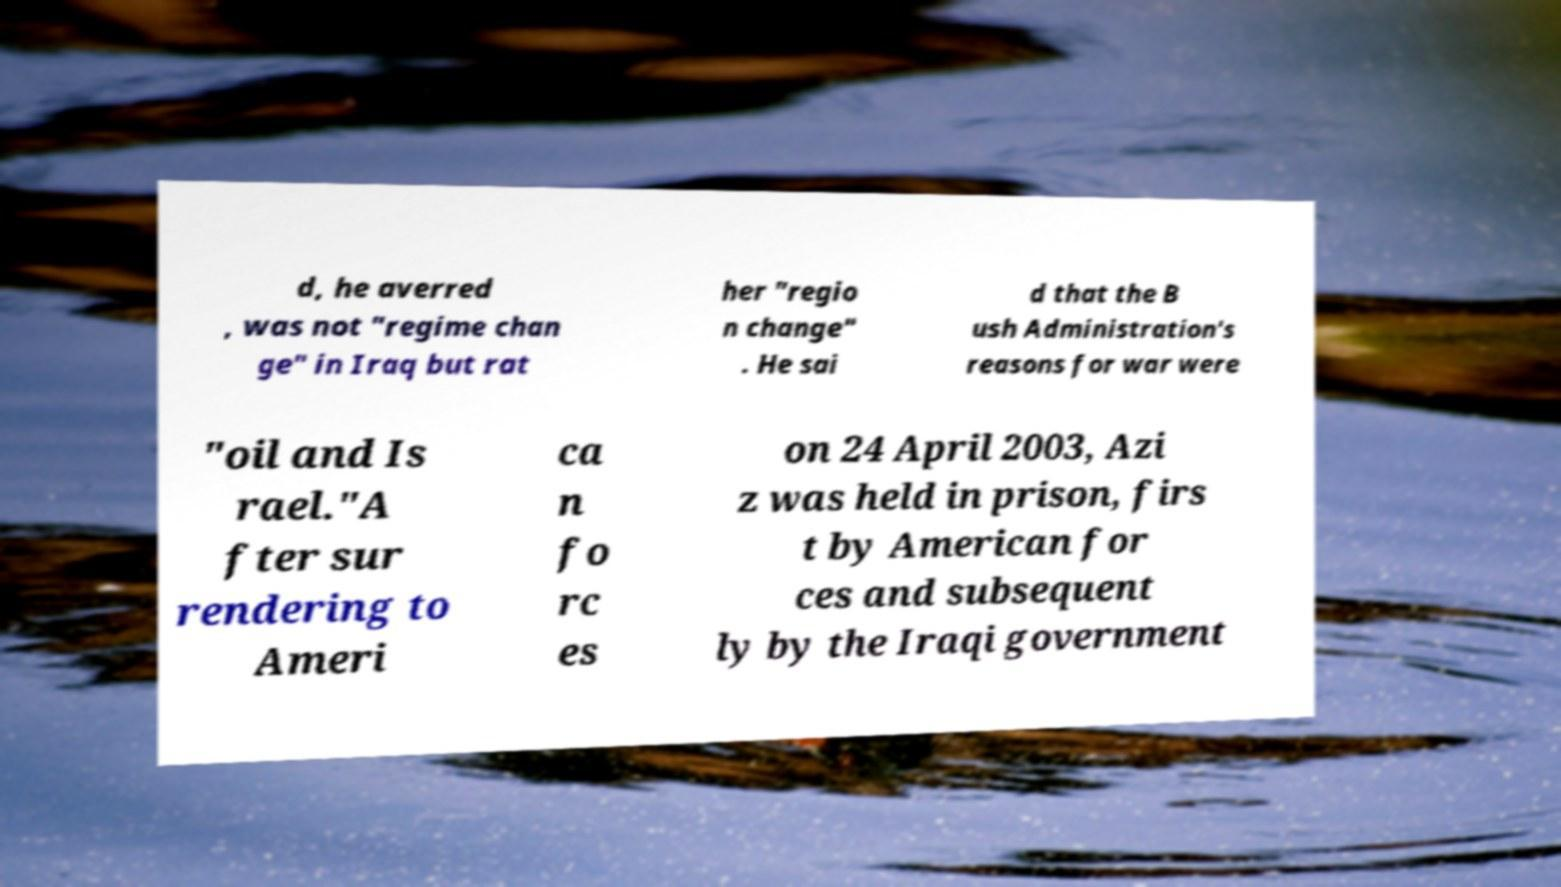Can you read and provide the text displayed in the image?This photo seems to have some interesting text. Can you extract and type it out for me? d, he averred , was not "regime chan ge" in Iraq but rat her "regio n change" . He sai d that the B ush Administration's reasons for war were "oil and Is rael."A fter sur rendering to Ameri ca n fo rc es on 24 April 2003, Azi z was held in prison, firs t by American for ces and subsequent ly by the Iraqi government 